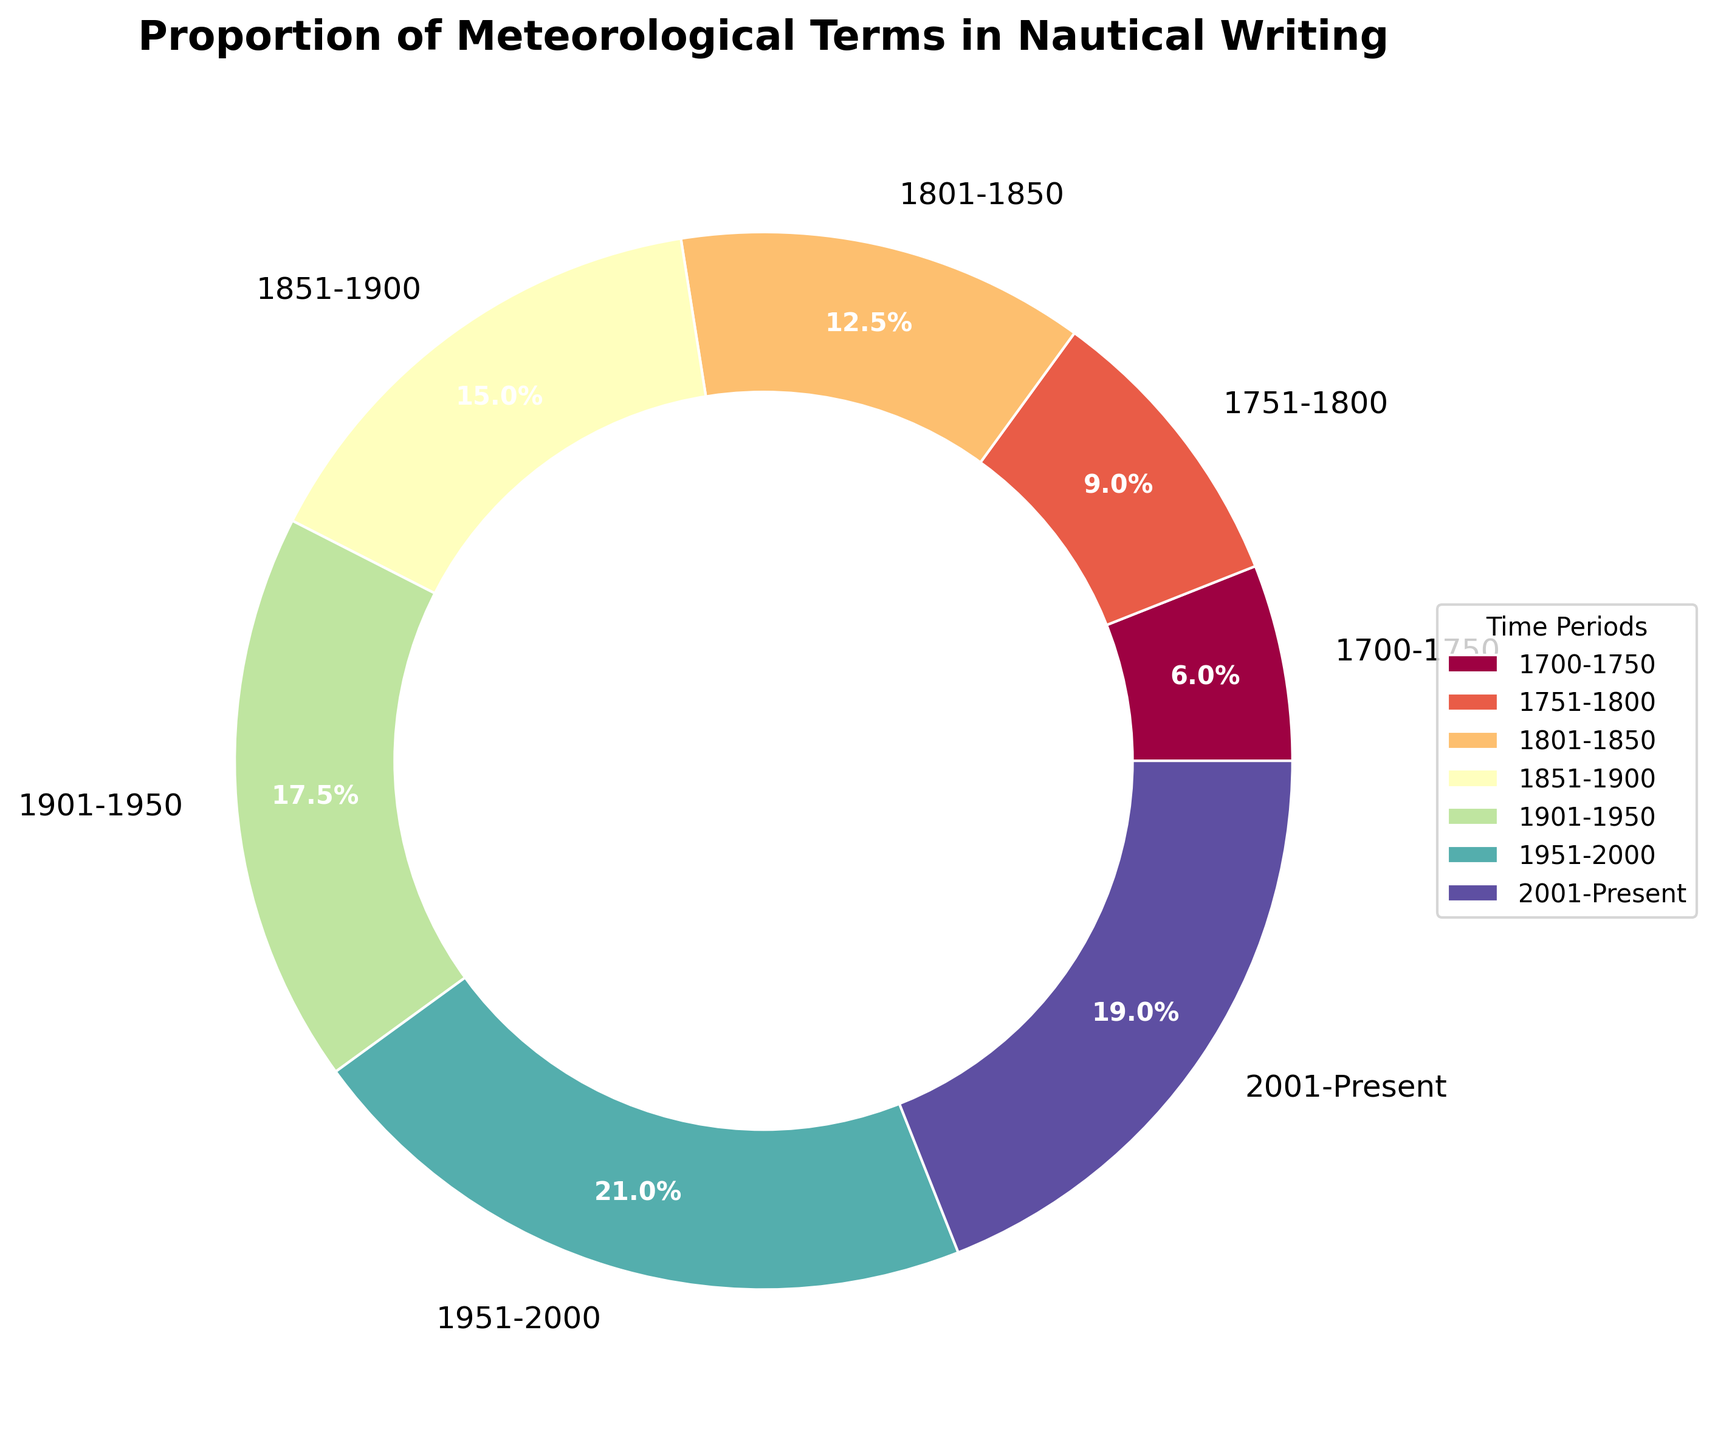What time period has the highest proportion of meteorological terms? By looking at the pie chart, observe which section of the pie has the largest percentage label. The 1951-2000 segment shows the highest proportion at 42%.
Answer: 1951-2000 How does the proportion of meteorological terms in 1700-1750 compare to 2001-Present? Compare the two percentages directly from the pie chart. The 1700-1750 period has 12%, while the 2001-Present period has 38%.
Answer: The 2001-Present period is higher What is the sum of the proportions for the periods 1801-1850 and 1901-1950? Add the proportions for 1801-1850 (25%) and 1901-1950 (35%). 25% + 35% = 60%.
Answer: 60% Which period between 1751-1800 and 1851-1900 has a greater proportion of meteorological terms? Compare the two percentages directly from the pie chart. The 1751-1800 period has 18%, while the 1851-1900 period has 30%.
Answer: 1851-1900 What is the difference in proportion between the periods 1951-2000 and 1851-1900? Subtract the proportion of 1851-1900 (30%) from the proportion of 1951-2000 (42%). 42% - 30% = 12%.
Answer: 12% Which period has an equal or closest proportion to 0.30? Check the pie chart to find the segment whose proportion is exactly 0.30 or closest. The period 1851-1900 has exactly 0.30.
Answer: 1851-1900 What is the average proportion of the periods from 1700 to 1850? Calculate the average of the proportions for 1700-1750 (12%), 1751-1800 (18%), and 1801-1850 (25%). (12 + 18 + 25) / 3 = 18.33%.
Answer: 18.33% By what percentage did the proportion increase from 1700-1750 to 1851-1900? Calculate the difference and then find the percentage increase: (30% - 12%) = 18%. Then, (18 / 12) * 100 ≈ 150%.
Answer: 150% Which time period represents the smallest proportion of meteorological terms used? Look at the pie chart to identify the segment with the smallest percentage. The 1700-1750 period shows the smallest proportion at 12%.
Answer: 1700-1750 